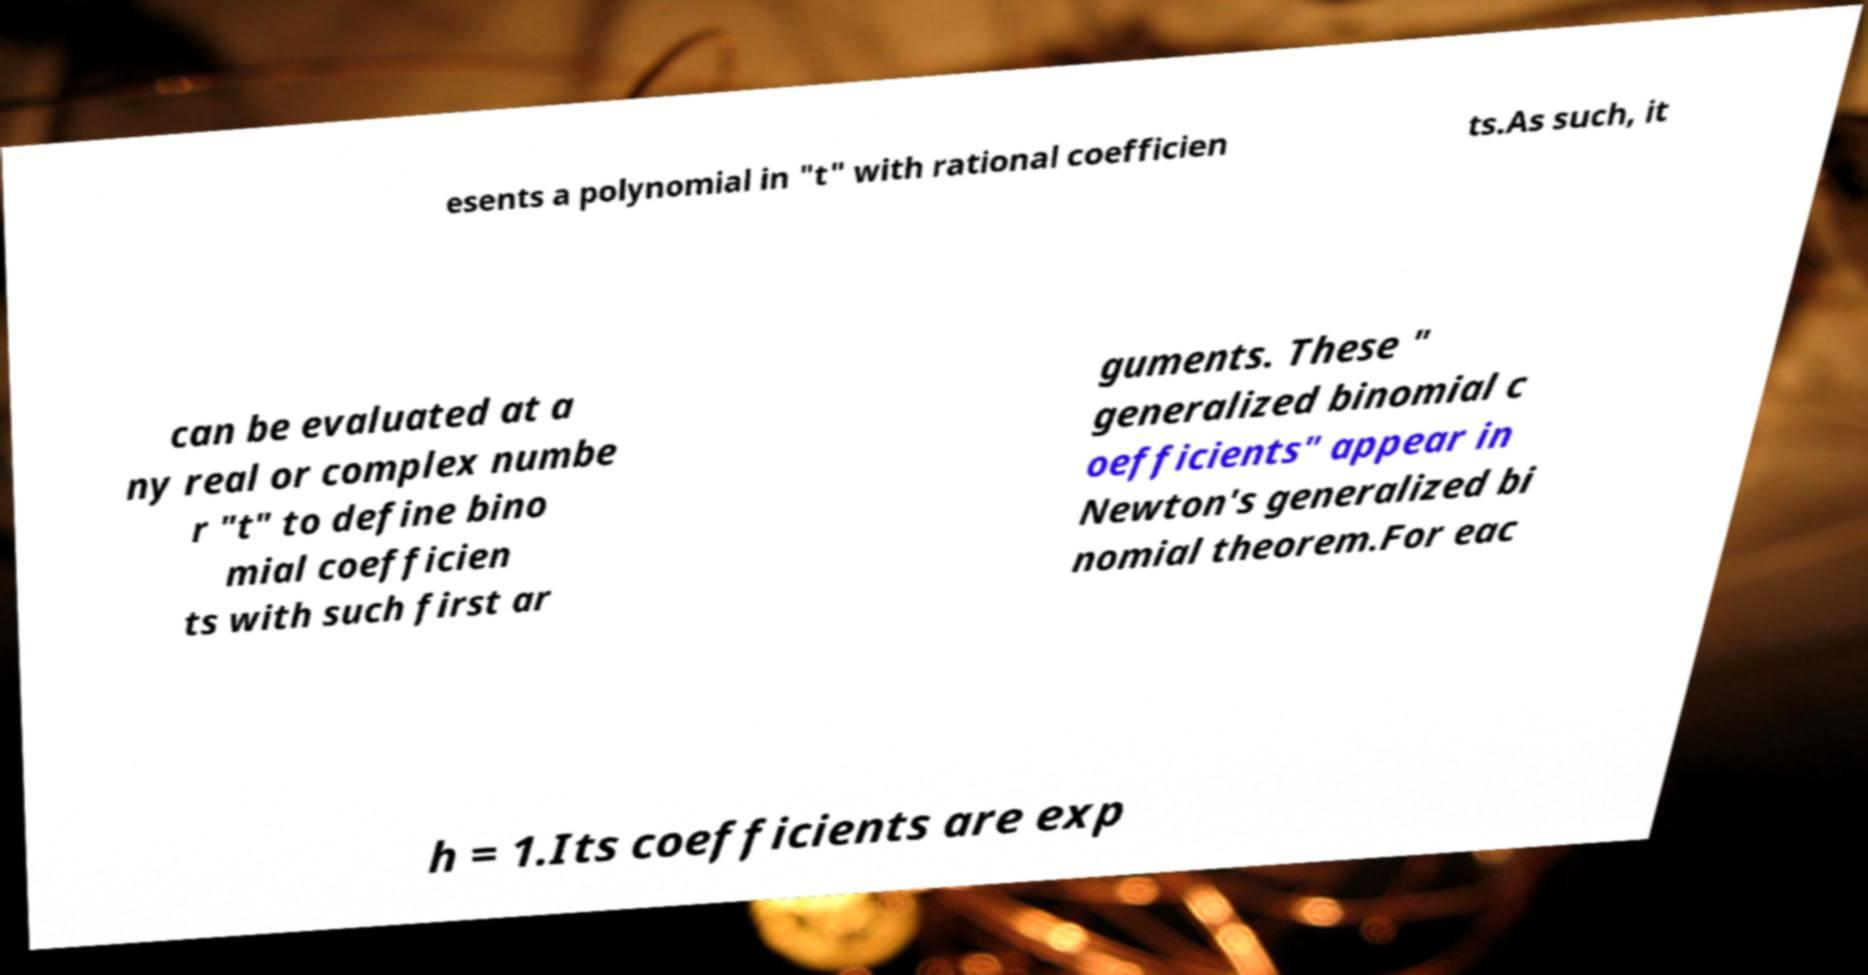Please read and relay the text visible in this image. What does it say? esents a polynomial in "t" with rational coefficien ts.As such, it can be evaluated at a ny real or complex numbe r "t" to define bino mial coefficien ts with such first ar guments. These " generalized binomial c oefficients" appear in Newton's generalized bi nomial theorem.For eac h = 1.Its coefficients are exp 